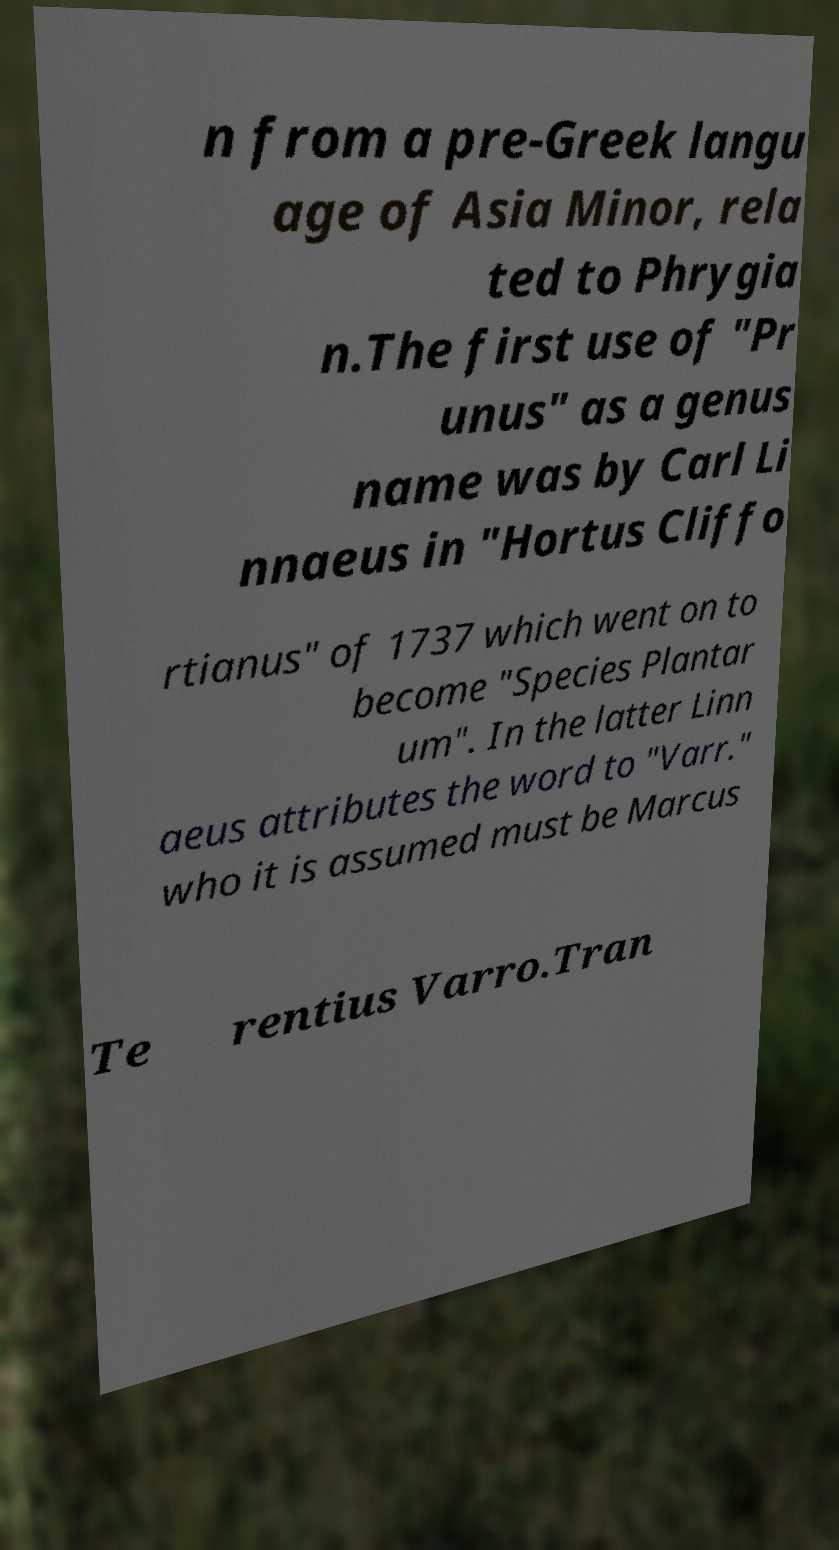I need the written content from this picture converted into text. Can you do that? n from a pre-Greek langu age of Asia Minor, rela ted to Phrygia n.The first use of "Pr unus" as a genus name was by Carl Li nnaeus in "Hortus Cliffo rtianus" of 1737 which went on to become "Species Plantar um". In the latter Linn aeus attributes the word to "Varr." who it is assumed must be Marcus Te rentius Varro.Tran 